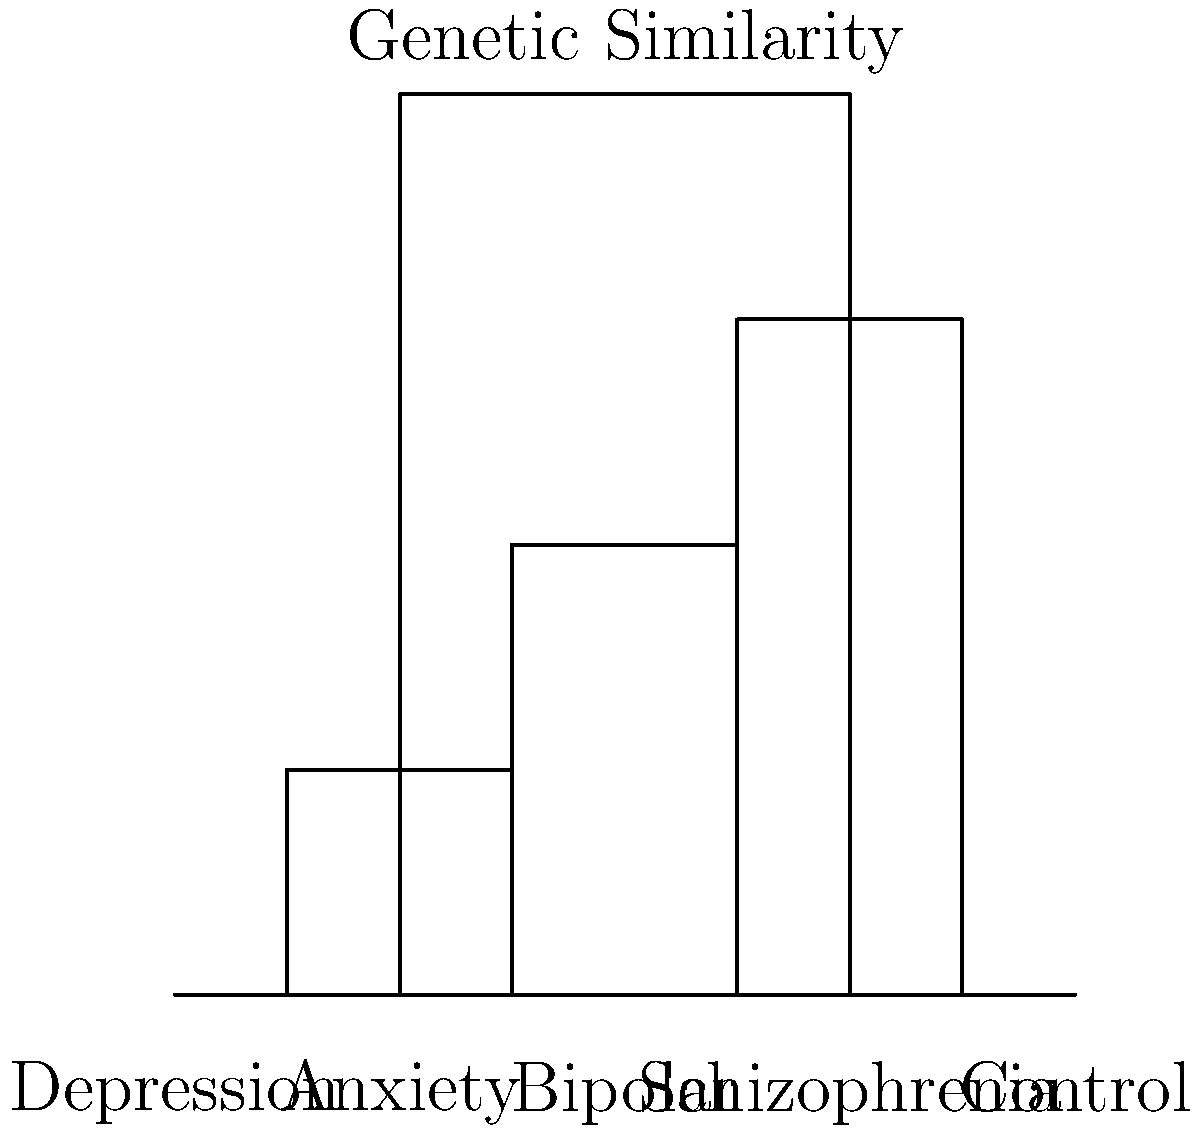Based on the dendrogram of genetic similarities among individuals with different mental health conditions, which two conditions appear to be most closely related genetically, and what might this suggest about their underlying biological mechanisms? To interpret this dendrogram and answer the question, we need to follow these steps:

1. Understand the dendrogram structure: In a dendrogram, items that cluster together at lower heights are more similar to each other.

2. Identify the closest pair: Looking at the dendrogram, we can see that Depression and Anxiety are joined at the lowest height, indicating they are the most genetically similar among the conditions shown.

3. Interpret the biological significance: The close genetic similarity between Depression and Anxiety suggests that these two conditions might share common underlying biological mechanisms. This could include:

   a) Similar genetic risk factors
   b) Overlapping neurobiological pathways
   c) Shared environmental triggers that interact with genetic predispositions

4. Consider the implications: This genetic similarity aligns with clinical observations of comorbidity between depression and anxiety disorders, supporting the idea of shared etiological factors.

5. Compare with other conditions: Note that Bipolar disorder clusters next closest to the Depression-Anxiety pair, while Schizophrenia is more distant. This suggests a spectrum of genetic relatedness among these conditions.

6. Observe the control group: The control group is the most genetically distant from all mental health conditions, as expected.

This interpretation provides insights into the potential shared biological underpinnings of depression and anxiety, which could inform future research directions in understanding and treating these conditions.
Answer: Depression and Anxiety; shared biological mechanisms 